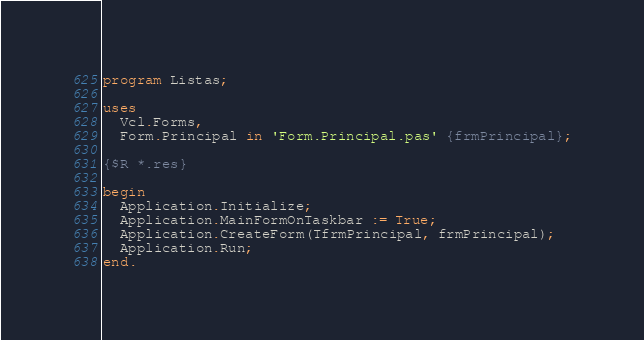<code> <loc_0><loc_0><loc_500><loc_500><_Pascal_>program Listas;

uses
  Vcl.Forms,
  Form.Principal in 'Form.Principal.pas' {frmPrincipal};

{$R *.res}

begin
  Application.Initialize;
  Application.MainFormOnTaskbar := True;
  Application.CreateForm(TfrmPrincipal, frmPrincipal);
  Application.Run;
end.
</code> 